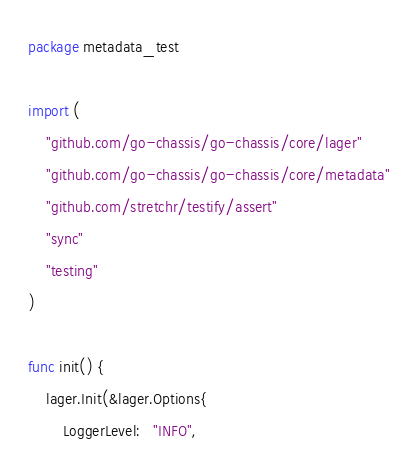Convert code to text. <code><loc_0><loc_0><loc_500><loc_500><_Go_>package metadata_test

import (
	"github.com/go-chassis/go-chassis/core/lager"
	"github.com/go-chassis/go-chassis/core/metadata"
	"github.com/stretchr/testify/assert"
	"sync"
	"testing"
)

func init() {
	lager.Init(&lager.Options{
		LoggerLevel:   "INFO",</code> 